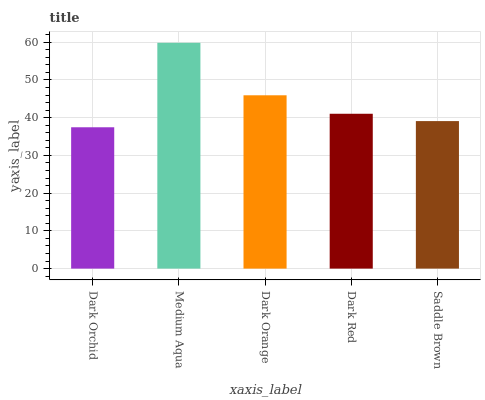Is Dark Orchid the minimum?
Answer yes or no. Yes. Is Medium Aqua the maximum?
Answer yes or no. Yes. Is Dark Orange the minimum?
Answer yes or no. No. Is Dark Orange the maximum?
Answer yes or no. No. Is Medium Aqua greater than Dark Orange?
Answer yes or no. Yes. Is Dark Orange less than Medium Aqua?
Answer yes or no. Yes. Is Dark Orange greater than Medium Aqua?
Answer yes or no. No. Is Medium Aqua less than Dark Orange?
Answer yes or no. No. Is Dark Red the high median?
Answer yes or no. Yes. Is Dark Red the low median?
Answer yes or no. Yes. Is Dark Orchid the high median?
Answer yes or no. No. Is Medium Aqua the low median?
Answer yes or no. No. 